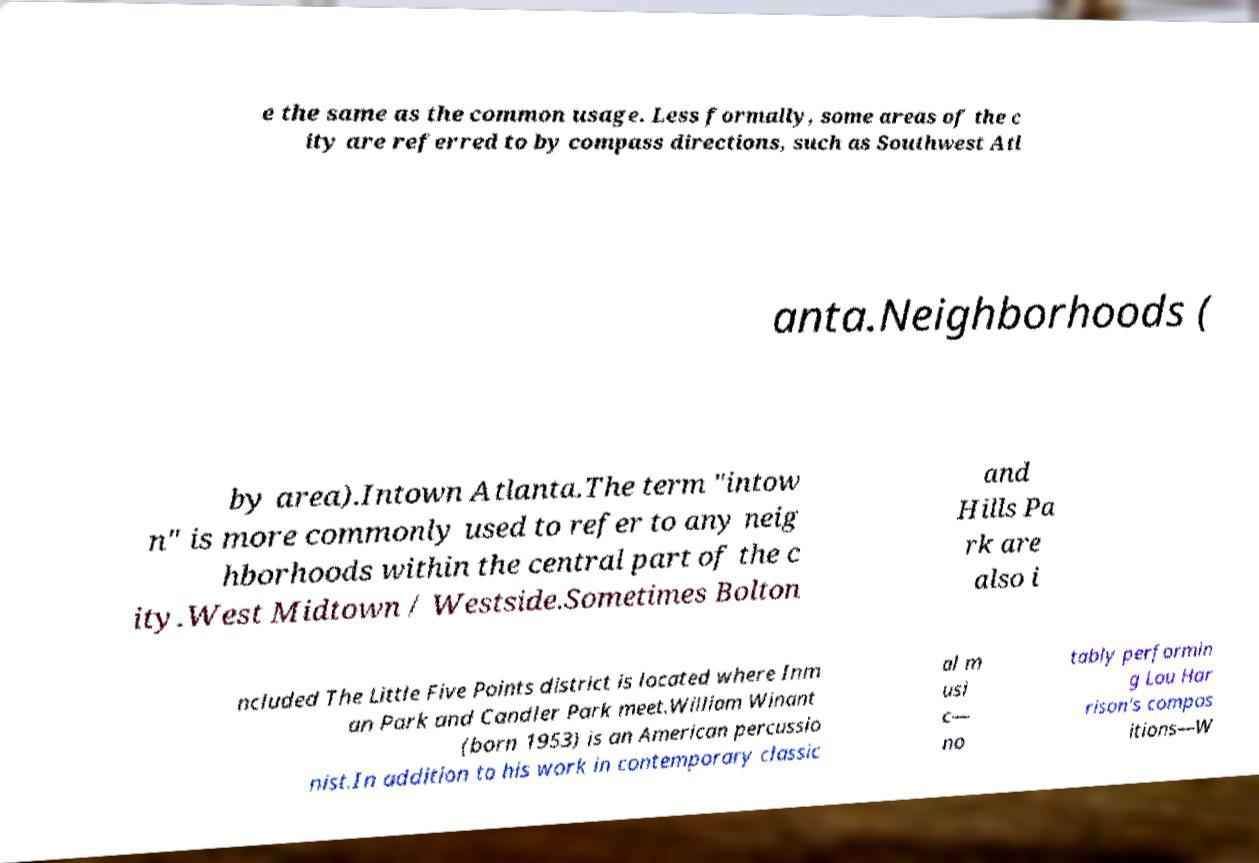Can you accurately transcribe the text from the provided image for me? e the same as the common usage. Less formally, some areas of the c ity are referred to by compass directions, such as Southwest Atl anta.Neighborhoods ( by area).Intown Atlanta.The term "intow n" is more commonly used to refer to any neig hborhoods within the central part of the c ity.West Midtown / Westside.Sometimes Bolton and Hills Pa rk are also i ncluded The Little Five Points district is located where Inm an Park and Candler Park meet.William Winant (born 1953) is an American percussio nist.In addition to his work in contemporary classic al m usi c— no tably performin g Lou Har rison's compos itions—W 